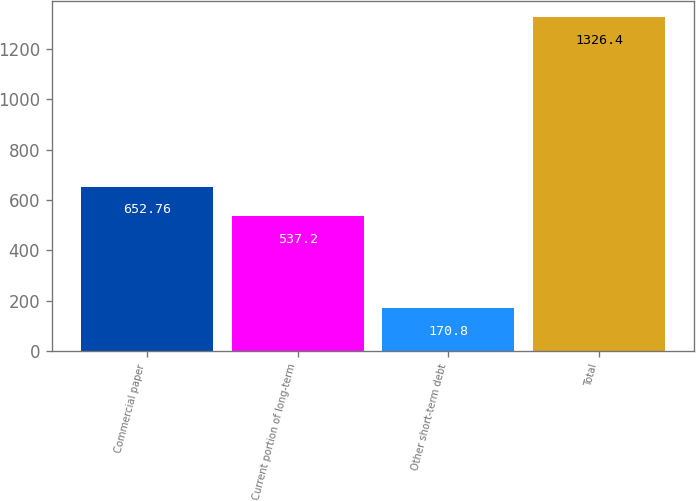Convert chart. <chart><loc_0><loc_0><loc_500><loc_500><bar_chart><fcel>Commercial paper<fcel>Current portion of long-term<fcel>Other short-term debt<fcel>Total<nl><fcel>652.76<fcel>537.2<fcel>170.8<fcel>1326.4<nl></chart> 